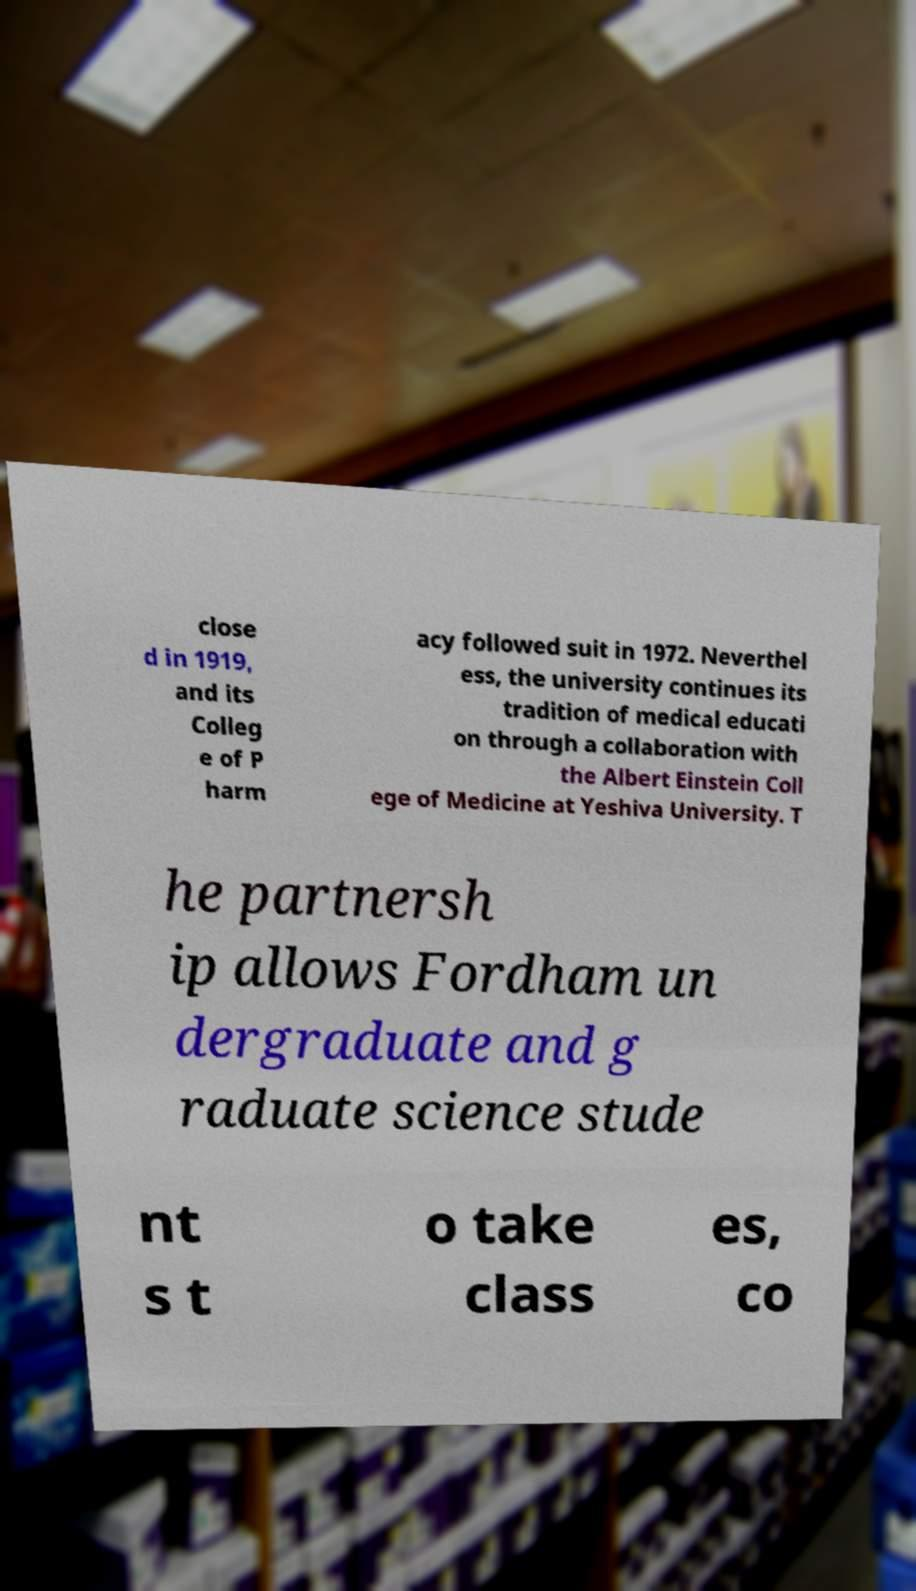Please identify and transcribe the text found in this image. close d in 1919, and its Colleg e of P harm acy followed suit in 1972. Neverthel ess, the university continues its tradition of medical educati on through a collaboration with the Albert Einstein Coll ege of Medicine at Yeshiva University. T he partnersh ip allows Fordham un dergraduate and g raduate science stude nt s t o take class es, co 